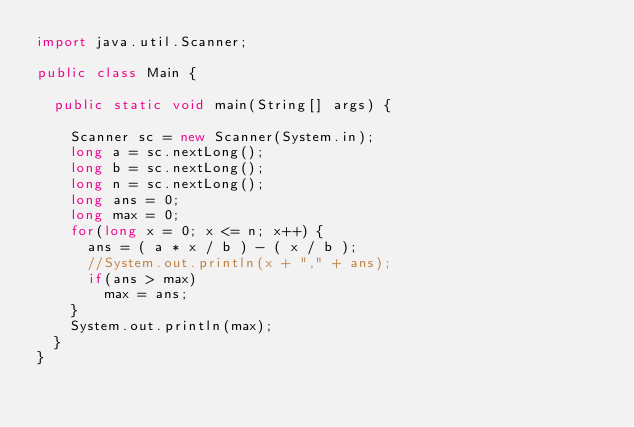<code> <loc_0><loc_0><loc_500><loc_500><_Java_>import java.util.Scanner;

public class Main {

	public static void main(String[] args) {

		Scanner sc = new Scanner(System.in);
		long a = sc.nextLong();
		long b = sc.nextLong();
		long n = sc.nextLong();
		long ans = 0;
		long max = 0;
		for(long x = 0; x <= n; x++) {
			ans = ( a * x / b ) - ( x / b );
			//System.out.println(x + "," + ans);
			if(ans > max)
				max = ans;
		}
		System.out.println(max);
	}
}
</code> 